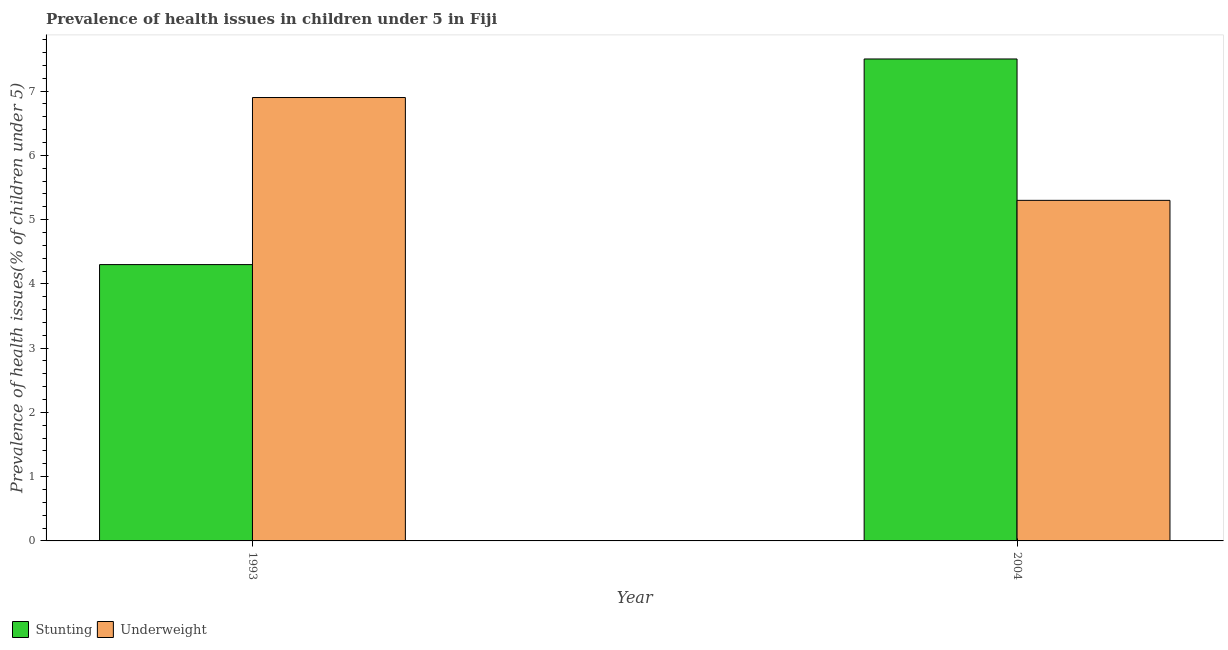How many groups of bars are there?
Ensure brevity in your answer.  2. Are the number of bars per tick equal to the number of legend labels?
Provide a succinct answer. Yes. Are the number of bars on each tick of the X-axis equal?
Your response must be concise. Yes. How many bars are there on the 2nd tick from the right?
Give a very brief answer. 2. In how many cases, is the number of bars for a given year not equal to the number of legend labels?
Make the answer very short. 0. What is the percentage of underweight children in 2004?
Your answer should be very brief. 5.3. Across all years, what is the maximum percentage of stunted children?
Your answer should be very brief. 7.5. Across all years, what is the minimum percentage of stunted children?
Give a very brief answer. 4.3. In which year was the percentage of underweight children minimum?
Offer a terse response. 2004. What is the total percentage of underweight children in the graph?
Your response must be concise. 12.2. What is the difference between the percentage of stunted children in 1993 and that in 2004?
Provide a short and direct response. -3.2. What is the difference between the percentage of underweight children in 1993 and the percentage of stunted children in 2004?
Ensure brevity in your answer.  1.6. What is the average percentage of underweight children per year?
Your response must be concise. 6.1. In how many years, is the percentage of underweight children greater than 5.6 %?
Keep it short and to the point. 1. What is the ratio of the percentage of stunted children in 1993 to that in 2004?
Ensure brevity in your answer.  0.57. Is the percentage of stunted children in 1993 less than that in 2004?
Provide a succinct answer. Yes. What does the 2nd bar from the left in 2004 represents?
Your answer should be very brief. Underweight. What does the 2nd bar from the right in 2004 represents?
Give a very brief answer. Stunting. Are all the bars in the graph horizontal?
Make the answer very short. No. Are the values on the major ticks of Y-axis written in scientific E-notation?
Make the answer very short. No. Does the graph contain any zero values?
Your response must be concise. No. Where does the legend appear in the graph?
Make the answer very short. Bottom left. How many legend labels are there?
Provide a succinct answer. 2. How are the legend labels stacked?
Ensure brevity in your answer.  Horizontal. What is the title of the graph?
Provide a short and direct response. Prevalence of health issues in children under 5 in Fiji. What is the label or title of the Y-axis?
Ensure brevity in your answer.  Prevalence of health issues(% of children under 5). What is the Prevalence of health issues(% of children under 5) of Stunting in 1993?
Provide a short and direct response. 4.3. What is the Prevalence of health issues(% of children under 5) of Underweight in 1993?
Make the answer very short. 6.9. What is the Prevalence of health issues(% of children under 5) of Underweight in 2004?
Your response must be concise. 5.3. Across all years, what is the maximum Prevalence of health issues(% of children under 5) of Underweight?
Offer a very short reply. 6.9. Across all years, what is the minimum Prevalence of health issues(% of children under 5) of Stunting?
Provide a short and direct response. 4.3. Across all years, what is the minimum Prevalence of health issues(% of children under 5) of Underweight?
Offer a very short reply. 5.3. What is the total Prevalence of health issues(% of children under 5) of Stunting in the graph?
Your response must be concise. 11.8. What is the total Prevalence of health issues(% of children under 5) of Underweight in the graph?
Give a very brief answer. 12.2. What is the difference between the Prevalence of health issues(% of children under 5) in Stunting in 1993 and that in 2004?
Your answer should be very brief. -3.2. What is the difference between the Prevalence of health issues(% of children under 5) in Underweight in 1993 and that in 2004?
Keep it short and to the point. 1.6. What is the difference between the Prevalence of health issues(% of children under 5) in Stunting in 1993 and the Prevalence of health issues(% of children under 5) in Underweight in 2004?
Ensure brevity in your answer.  -1. What is the average Prevalence of health issues(% of children under 5) in Stunting per year?
Your response must be concise. 5.9. What is the average Prevalence of health issues(% of children under 5) in Underweight per year?
Make the answer very short. 6.1. In the year 2004, what is the difference between the Prevalence of health issues(% of children under 5) of Stunting and Prevalence of health issues(% of children under 5) of Underweight?
Give a very brief answer. 2.2. What is the ratio of the Prevalence of health issues(% of children under 5) in Stunting in 1993 to that in 2004?
Provide a short and direct response. 0.57. What is the ratio of the Prevalence of health issues(% of children under 5) in Underweight in 1993 to that in 2004?
Make the answer very short. 1.3. What is the difference between the highest and the second highest Prevalence of health issues(% of children under 5) in Stunting?
Provide a succinct answer. 3.2. What is the difference between the highest and the second highest Prevalence of health issues(% of children under 5) of Underweight?
Provide a succinct answer. 1.6. What is the difference between the highest and the lowest Prevalence of health issues(% of children under 5) in Underweight?
Make the answer very short. 1.6. 